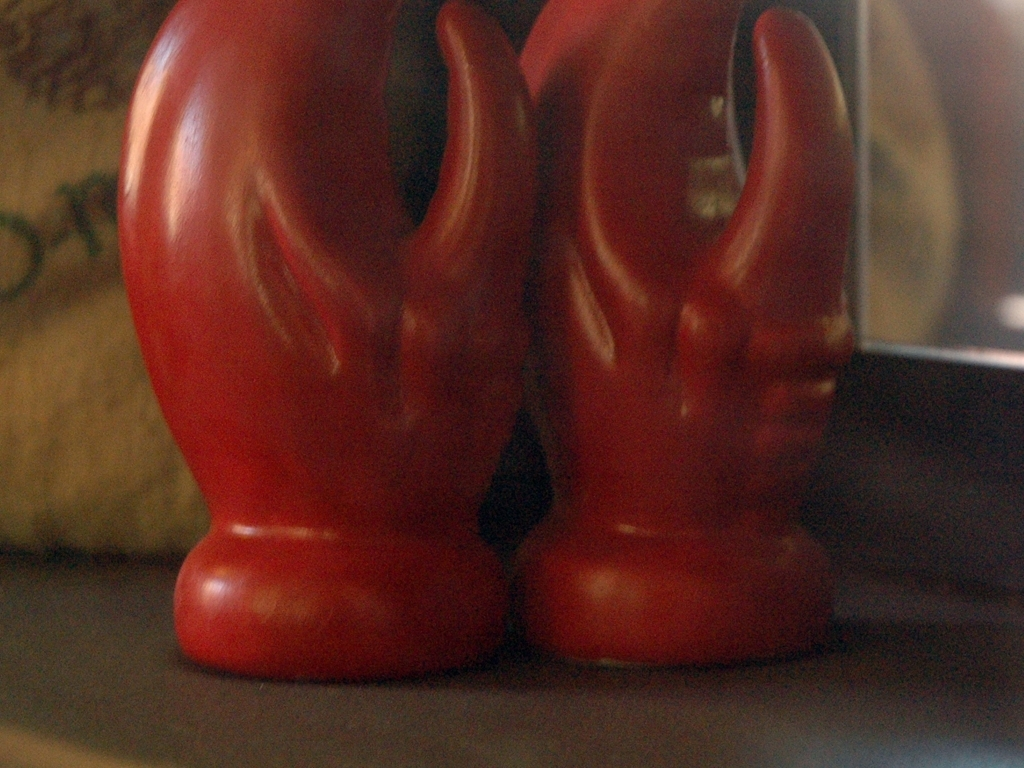What artistic aspects can you comment on regarding the items in the photo? Despite the poor image quality, the vibrant red color of the statues stands out, indicating that color is a significant aspect of their design. The smooth curves and stylized form suggest a modern or abstract artistic influence. Could the blurriness of the photo be intentional for artistic effect? It's possible that the blurriness is an artistic choice, intended to create a sense of movement or to draw attention to certain features by obscuring others. However, without further context, it's difficult to ascertain the photographer's intent. 